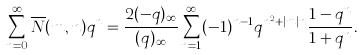<formula> <loc_0><loc_0><loc_500><loc_500>\sum _ { n = 0 } ^ { \infty } \overline { N } ( m , n ) q ^ { n } = \frac { 2 ( - q ) _ { \infty } } { ( q ) _ { \infty } } \sum _ { n = 1 } ^ { \infty } ( - 1 ) ^ { n - 1 } q ^ { n ^ { 2 } + | m | n } \frac { 1 - q ^ { n } } { 1 + q ^ { n } } .</formula> 